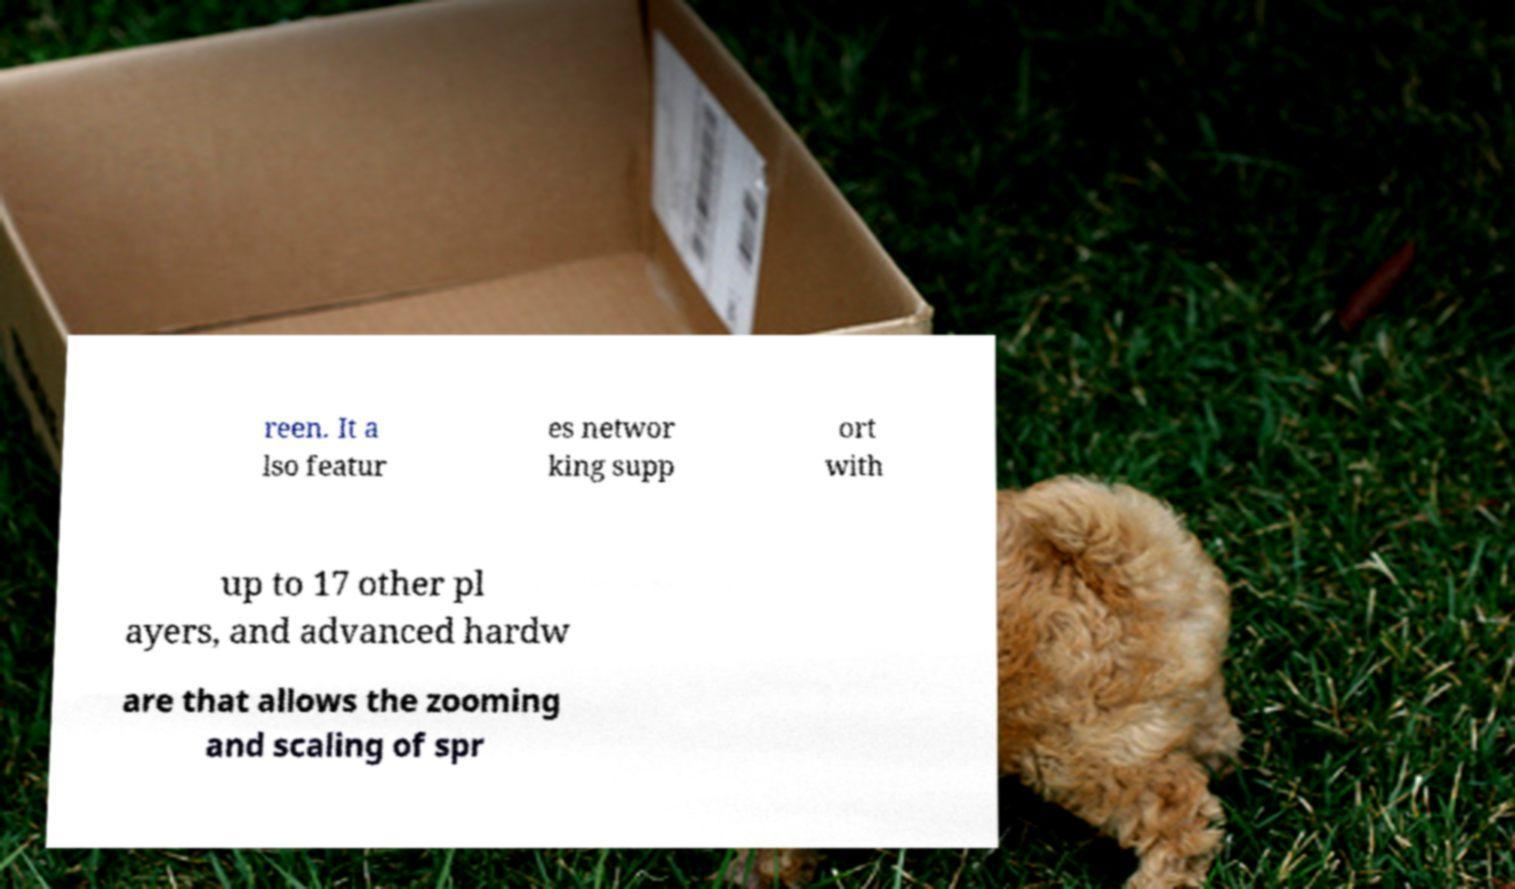For documentation purposes, I need the text within this image transcribed. Could you provide that? reen. It a lso featur es networ king supp ort with up to 17 other pl ayers, and advanced hardw are that allows the zooming and scaling of spr 